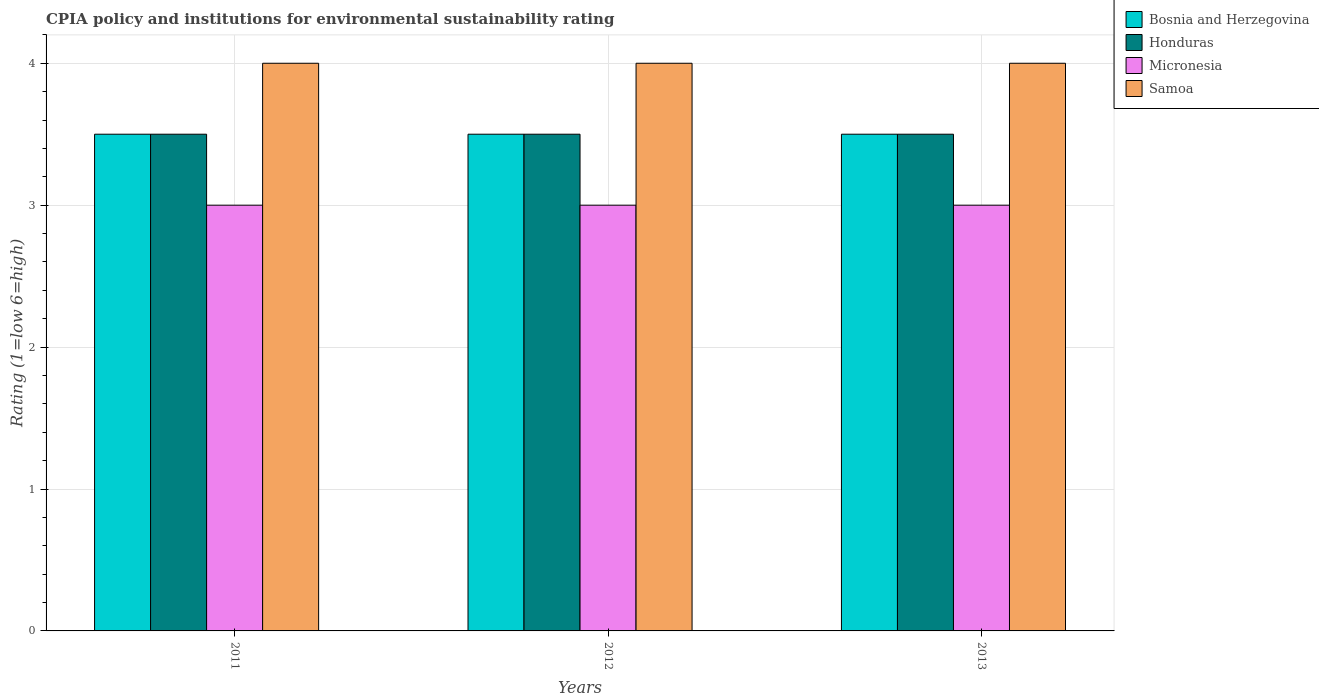How many bars are there on the 3rd tick from the left?
Ensure brevity in your answer.  4. How many bars are there on the 2nd tick from the right?
Offer a very short reply. 4. What is the label of the 2nd group of bars from the left?
Make the answer very short. 2012. In how many cases, is the number of bars for a given year not equal to the number of legend labels?
Offer a very short reply. 0. What is the CPIA rating in Micronesia in 2013?
Provide a short and direct response. 3. In which year was the CPIA rating in Micronesia maximum?
Offer a terse response. 2011. In which year was the CPIA rating in Micronesia minimum?
Your response must be concise. 2011. What is the total CPIA rating in Bosnia and Herzegovina in the graph?
Give a very brief answer. 10.5. What is the difference between the CPIA rating in Samoa in 2012 and that in 2013?
Offer a terse response. 0. What is the difference between the CPIA rating in Honduras in 2012 and the CPIA rating in Micronesia in 2013?
Provide a succinct answer. 0.5. What is the average CPIA rating in Samoa per year?
Provide a short and direct response. 4. In the year 2011, what is the difference between the CPIA rating in Honduras and CPIA rating in Micronesia?
Offer a very short reply. 0.5. Is the difference between the CPIA rating in Honduras in 2011 and 2012 greater than the difference between the CPIA rating in Micronesia in 2011 and 2012?
Your response must be concise. No. What is the difference between the highest and the second highest CPIA rating in Micronesia?
Give a very brief answer. 0. What is the difference between the highest and the lowest CPIA rating in Bosnia and Herzegovina?
Make the answer very short. 0. In how many years, is the CPIA rating in Bosnia and Herzegovina greater than the average CPIA rating in Bosnia and Herzegovina taken over all years?
Make the answer very short. 0. What does the 4th bar from the left in 2011 represents?
Keep it short and to the point. Samoa. What does the 2nd bar from the right in 2013 represents?
Your answer should be very brief. Micronesia. How many bars are there?
Offer a terse response. 12. Are all the bars in the graph horizontal?
Your answer should be compact. No. How many years are there in the graph?
Your response must be concise. 3. What is the difference between two consecutive major ticks on the Y-axis?
Keep it short and to the point. 1. Does the graph contain any zero values?
Offer a terse response. No. What is the title of the graph?
Keep it short and to the point. CPIA policy and institutions for environmental sustainability rating. Does "Austria" appear as one of the legend labels in the graph?
Keep it short and to the point. No. What is the Rating (1=low 6=high) of Bosnia and Herzegovina in 2011?
Your answer should be compact. 3.5. What is the Rating (1=low 6=high) of Samoa in 2011?
Give a very brief answer. 4. What is the Rating (1=low 6=high) of Bosnia and Herzegovina in 2012?
Offer a terse response. 3.5. What is the Rating (1=low 6=high) of Honduras in 2012?
Your answer should be compact. 3.5. What is the Rating (1=low 6=high) in Micronesia in 2012?
Keep it short and to the point. 3. What is the Rating (1=low 6=high) of Samoa in 2012?
Your answer should be very brief. 4. What is the Rating (1=low 6=high) in Bosnia and Herzegovina in 2013?
Keep it short and to the point. 3.5. What is the Rating (1=low 6=high) of Micronesia in 2013?
Offer a terse response. 3. Across all years, what is the maximum Rating (1=low 6=high) in Bosnia and Herzegovina?
Make the answer very short. 3.5. Across all years, what is the minimum Rating (1=low 6=high) of Honduras?
Offer a terse response. 3.5. Across all years, what is the minimum Rating (1=low 6=high) in Samoa?
Your response must be concise. 4. What is the total Rating (1=low 6=high) of Bosnia and Herzegovina in the graph?
Your response must be concise. 10.5. What is the total Rating (1=low 6=high) of Honduras in the graph?
Make the answer very short. 10.5. What is the total Rating (1=low 6=high) of Samoa in the graph?
Your response must be concise. 12. What is the difference between the Rating (1=low 6=high) in Samoa in 2011 and that in 2012?
Provide a succinct answer. 0. What is the difference between the Rating (1=low 6=high) in Bosnia and Herzegovina in 2011 and that in 2013?
Your answer should be compact. 0. What is the difference between the Rating (1=low 6=high) in Honduras in 2012 and that in 2013?
Provide a short and direct response. 0. What is the difference between the Rating (1=low 6=high) of Micronesia in 2012 and that in 2013?
Keep it short and to the point. 0. What is the difference between the Rating (1=low 6=high) of Bosnia and Herzegovina in 2011 and the Rating (1=low 6=high) of Micronesia in 2012?
Provide a short and direct response. 0.5. What is the difference between the Rating (1=low 6=high) in Honduras in 2011 and the Rating (1=low 6=high) in Micronesia in 2012?
Offer a very short reply. 0.5. What is the difference between the Rating (1=low 6=high) of Micronesia in 2011 and the Rating (1=low 6=high) of Samoa in 2012?
Your answer should be compact. -1. What is the difference between the Rating (1=low 6=high) in Bosnia and Herzegovina in 2011 and the Rating (1=low 6=high) in Micronesia in 2013?
Your answer should be very brief. 0.5. What is the difference between the Rating (1=low 6=high) of Bosnia and Herzegovina in 2011 and the Rating (1=low 6=high) of Samoa in 2013?
Your answer should be compact. -0.5. What is the difference between the Rating (1=low 6=high) in Micronesia in 2011 and the Rating (1=low 6=high) in Samoa in 2013?
Offer a terse response. -1. What is the difference between the Rating (1=low 6=high) in Bosnia and Herzegovina in 2012 and the Rating (1=low 6=high) in Honduras in 2013?
Offer a terse response. 0. What is the difference between the Rating (1=low 6=high) in Bosnia and Herzegovina in 2012 and the Rating (1=low 6=high) in Micronesia in 2013?
Your answer should be very brief. 0.5. What is the difference between the Rating (1=low 6=high) of Honduras in 2012 and the Rating (1=low 6=high) of Samoa in 2013?
Keep it short and to the point. -0.5. What is the average Rating (1=low 6=high) of Bosnia and Herzegovina per year?
Keep it short and to the point. 3.5. What is the average Rating (1=low 6=high) in Honduras per year?
Offer a very short reply. 3.5. What is the average Rating (1=low 6=high) in Micronesia per year?
Give a very brief answer. 3. What is the average Rating (1=low 6=high) in Samoa per year?
Offer a terse response. 4. In the year 2011, what is the difference between the Rating (1=low 6=high) in Bosnia and Herzegovina and Rating (1=low 6=high) in Samoa?
Offer a very short reply. -0.5. In the year 2011, what is the difference between the Rating (1=low 6=high) in Micronesia and Rating (1=low 6=high) in Samoa?
Your answer should be very brief. -1. In the year 2012, what is the difference between the Rating (1=low 6=high) in Bosnia and Herzegovina and Rating (1=low 6=high) in Honduras?
Provide a succinct answer. 0. In the year 2012, what is the difference between the Rating (1=low 6=high) in Honduras and Rating (1=low 6=high) in Micronesia?
Your answer should be compact. 0.5. In the year 2012, what is the difference between the Rating (1=low 6=high) in Honduras and Rating (1=low 6=high) in Samoa?
Your answer should be very brief. -0.5. In the year 2013, what is the difference between the Rating (1=low 6=high) of Bosnia and Herzegovina and Rating (1=low 6=high) of Honduras?
Offer a terse response. 0. In the year 2013, what is the difference between the Rating (1=low 6=high) of Honduras and Rating (1=low 6=high) of Micronesia?
Offer a terse response. 0.5. In the year 2013, what is the difference between the Rating (1=low 6=high) in Honduras and Rating (1=low 6=high) in Samoa?
Provide a short and direct response. -0.5. What is the ratio of the Rating (1=low 6=high) in Bosnia and Herzegovina in 2011 to that in 2013?
Your response must be concise. 1. What is the ratio of the Rating (1=low 6=high) in Honduras in 2012 to that in 2013?
Keep it short and to the point. 1. What is the ratio of the Rating (1=low 6=high) of Micronesia in 2012 to that in 2013?
Your answer should be compact. 1. What is the difference between the highest and the second highest Rating (1=low 6=high) of Micronesia?
Make the answer very short. 0. What is the difference between the highest and the lowest Rating (1=low 6=high) of Bosnia and Herzegovina?
Make the answer very short. 0. 